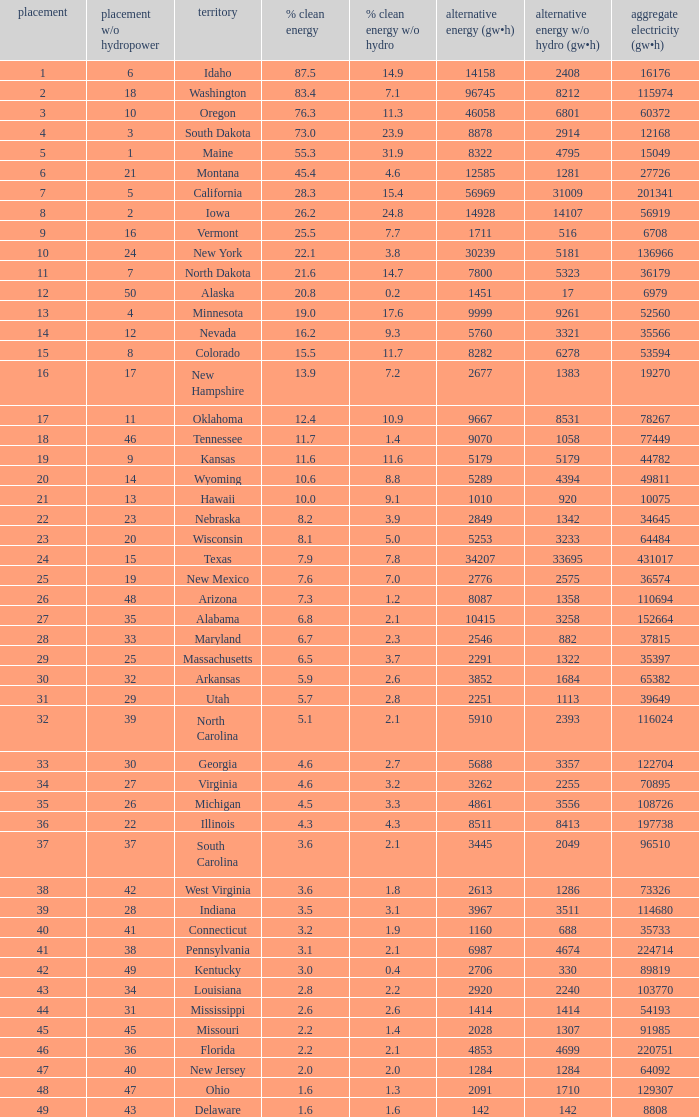What is the percentage of renewable electricity without hydrogen power in the state of South Dakota? 23.9. 